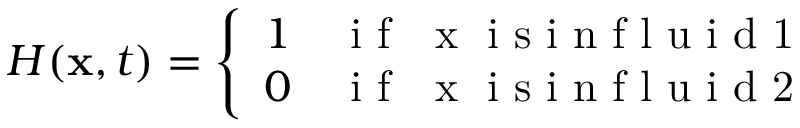<formula> <loc_0><loc_0><loc_500><loc_500>\begin{array} { r } { H ( x , t ) = \left \{ \begin{array} { l l } { 1 \quad i f \mathbf { x } i s i n f l u i d 1 } \\ { 0 \quad i f \mathbf { x } i s i n f l u i d 2 } \end{array} } \end{array}</formula> 